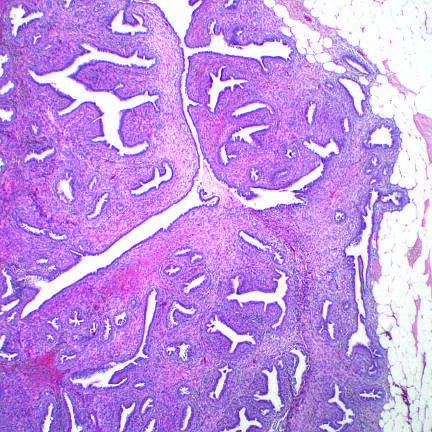do proliferating stromal cells distort the glandular tissue, forming cleftlike spaces, and bulge into surrounding stroma?
Answer the question using a single word or phrase. Yes 